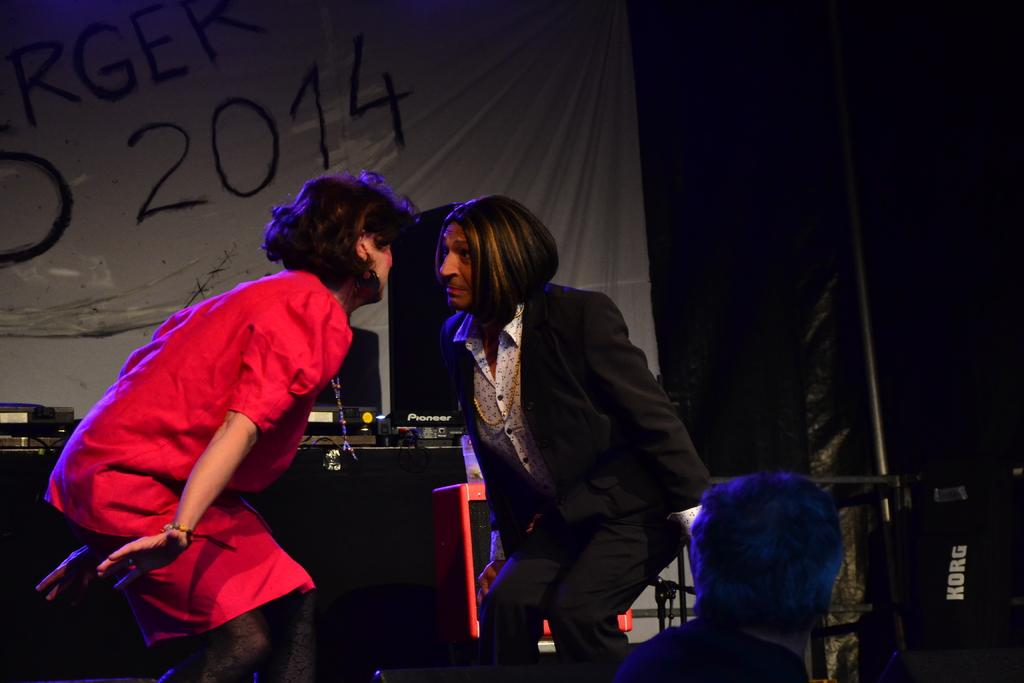How many people are in the image? There are two people in the image. What colors are the people wearing? The people are wearing red, black, and white color dresses. What can be seen in the background of the image? There are objects visible in the background, including a white color banner. What is the color of the background in the image? The background is black in color. What type of animal can be seen in the image? There is no animal present in the image. Where is the hospital located in the image? There is no hospital present in the image. What type of meeting is taking place in the image? There is no meeting taking place in the image. 